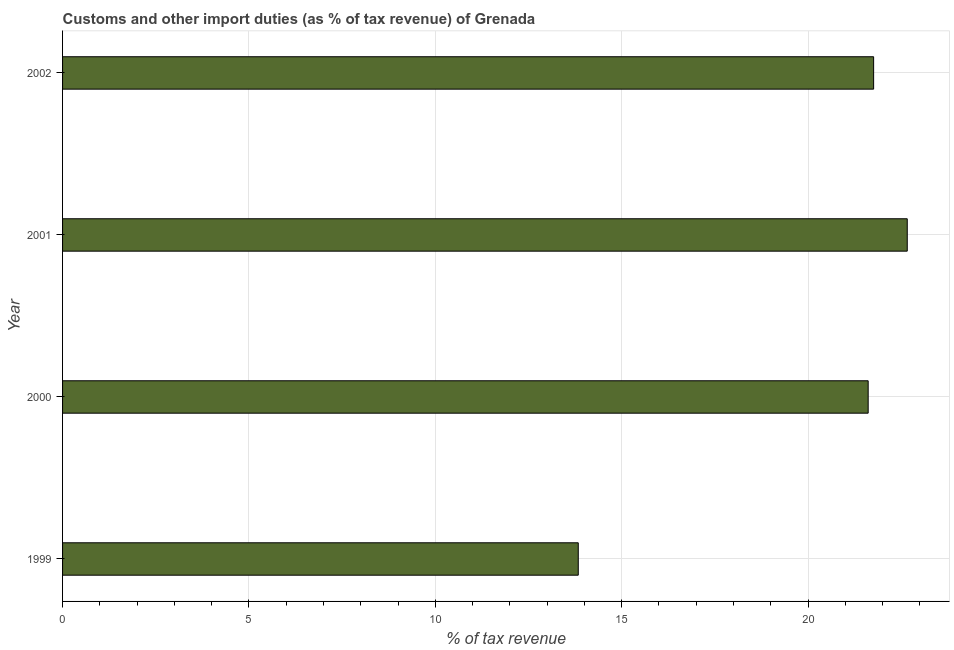Does the graph contain any zero values?
Your answer should be very brief. No. What is the title of the graph?
Your response must be concise. Customs and other import duties (as % of tax revenue) of Grenada. What is the label or title of the X-axis?
Your answer should be compact. % of tax revenue. What is the label or title of the Y-axis?
Ensure brevity in your answer.  Year. What is the customs and other import duties in 2000?
Offer a terse response. 21.61. Across all years, what is the maximum customs and other import duties?
Your answer should be very brief. 22.66. Across all years, what is the minimum customs and other import duties?
Your answer should be very brief. 13.84. In which year was the customs and other import duties minimum?
Provide a succinct answer. 1999. What is the sum of the customs and other import duties?
Ensure brevity in your answer.  79.87. What is the difference between the customs and other import duties in 2000 and 2001?
Offer a terse response. -1.05. What is the average customs and other import duties per year?
Offer a very short reply. 19.97. What is the median customs and other import duties?
Ensure brevity in your answer.  21.69. Do a majority of the years between 1999 and 2001 (inclusive) have customs and other import duties greater than 18 %?
Offer a terse response. Yes. What is the ratio of the customs and other import duties in 1999 to that in 2002?
Keep it short and to the point. 0.64. Is the customs and other import duties in 2000 less than that in 2001?
Make the answer very short. Yes. What is the difference between the highest and the second highest customs and other import duties?
Offer a terse response. 0.9. What is the difference between the highest and the lowest customs and other import duties?
Offer a terse response. 8.83. How many bars are there?
Give a very brief answer. 4. What is the difference between two consecutive major ticks on the X-axis?
Offer a very short reply. 5. What is the % of tax revenue in 1999?
Provide a short and direct response. 13.84. What is the % of tax revenue of 2000?
Your answer should be compact. 21.61. What is the % of tax revenue in 2001?
Your answer should be very brief. 22.66. What is the % of tax revenue in 2002?
Your response must be concise. 21.76. What is the difference between the % of tax revenue in 1999 and 2000?
Provide a succinct answer. -7.78. What is the difference between the % of tax revenue in 1999 and 2001?
Offer a terse response. -8.83. What is the difference between the % of tax revenue in 1999 and 2002?
Make the answer very short. -7.92. What is the difference between the % of tax revenue in 2000 and 2001?
Ensure brevity in your answer.  -1.05. What is the difference between the % of tax revenue in 2000 and 2002?
Give a very brief answer. -0.15. What is the difference between the % of tax revenue in 2001 and 2002?
Provide a succinct answer. 0.9. What is the ratio of the % of tax revenue in 1999 to that in 2000?
Offer a very short reply. 0.64. What is the ratio of the % of tax revenue in 1999 to that in 2001?
Provide a succinct answer. 0.61. What is the ratio of the % of tax revenue in 1999 to that in 2002?
Keep it short and to the point. 0.64. What is the ratio of the % of tax revenue in 2000 to that in 2001?
Your response must be concise. 0.95. What is the ratio of the % of tax revenue in 2000 to that in 2002?
Your response must be concise. 0.99. What is the ratio of the % of tax revenue in 2001 to that in 2002?
Give a very brief answer. 1.04. 